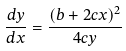<formula> <loc_0><loc_0><loc_500><loc_500>\frac { d y } { d x } = \frac { ( b + 2 c x ) ^ { 2 } } { 4 c y }</formula> 